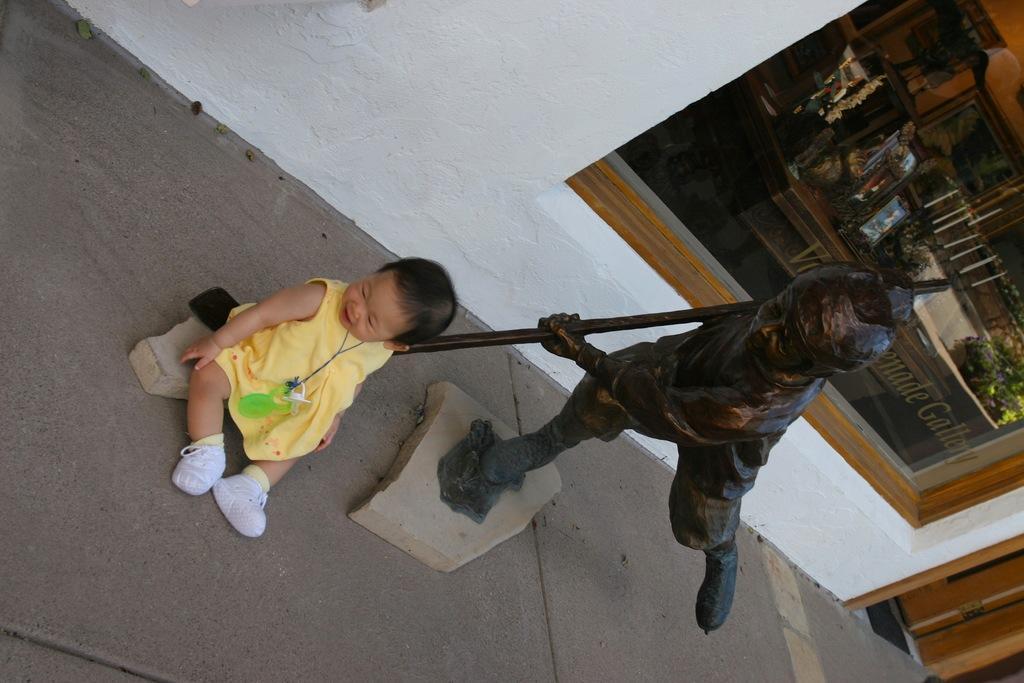Describe this image in one or two sentences. This picture is clicked inside. On the left there is a kid wearing a yellow color dress and sitting on the ground. On the right we can see the sculpture of a person holding a stick. In the background there is a wall and we can see the window and through the window we can see the picture frames, houseplant and some other objects and we can see the door and there is a text. 